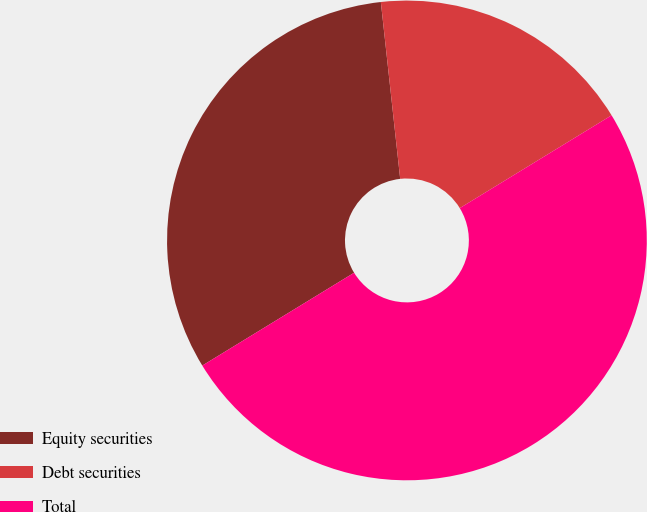Convert chart. <chart><loc_0><loc_0><loc_500><loc_500><pie_chart><fcel>Equity securities<fcel>Debt securities<fcel>Total<nl><fcel>32.0%<fcel>18.0%<fcel>50.0%<nl></chart> 